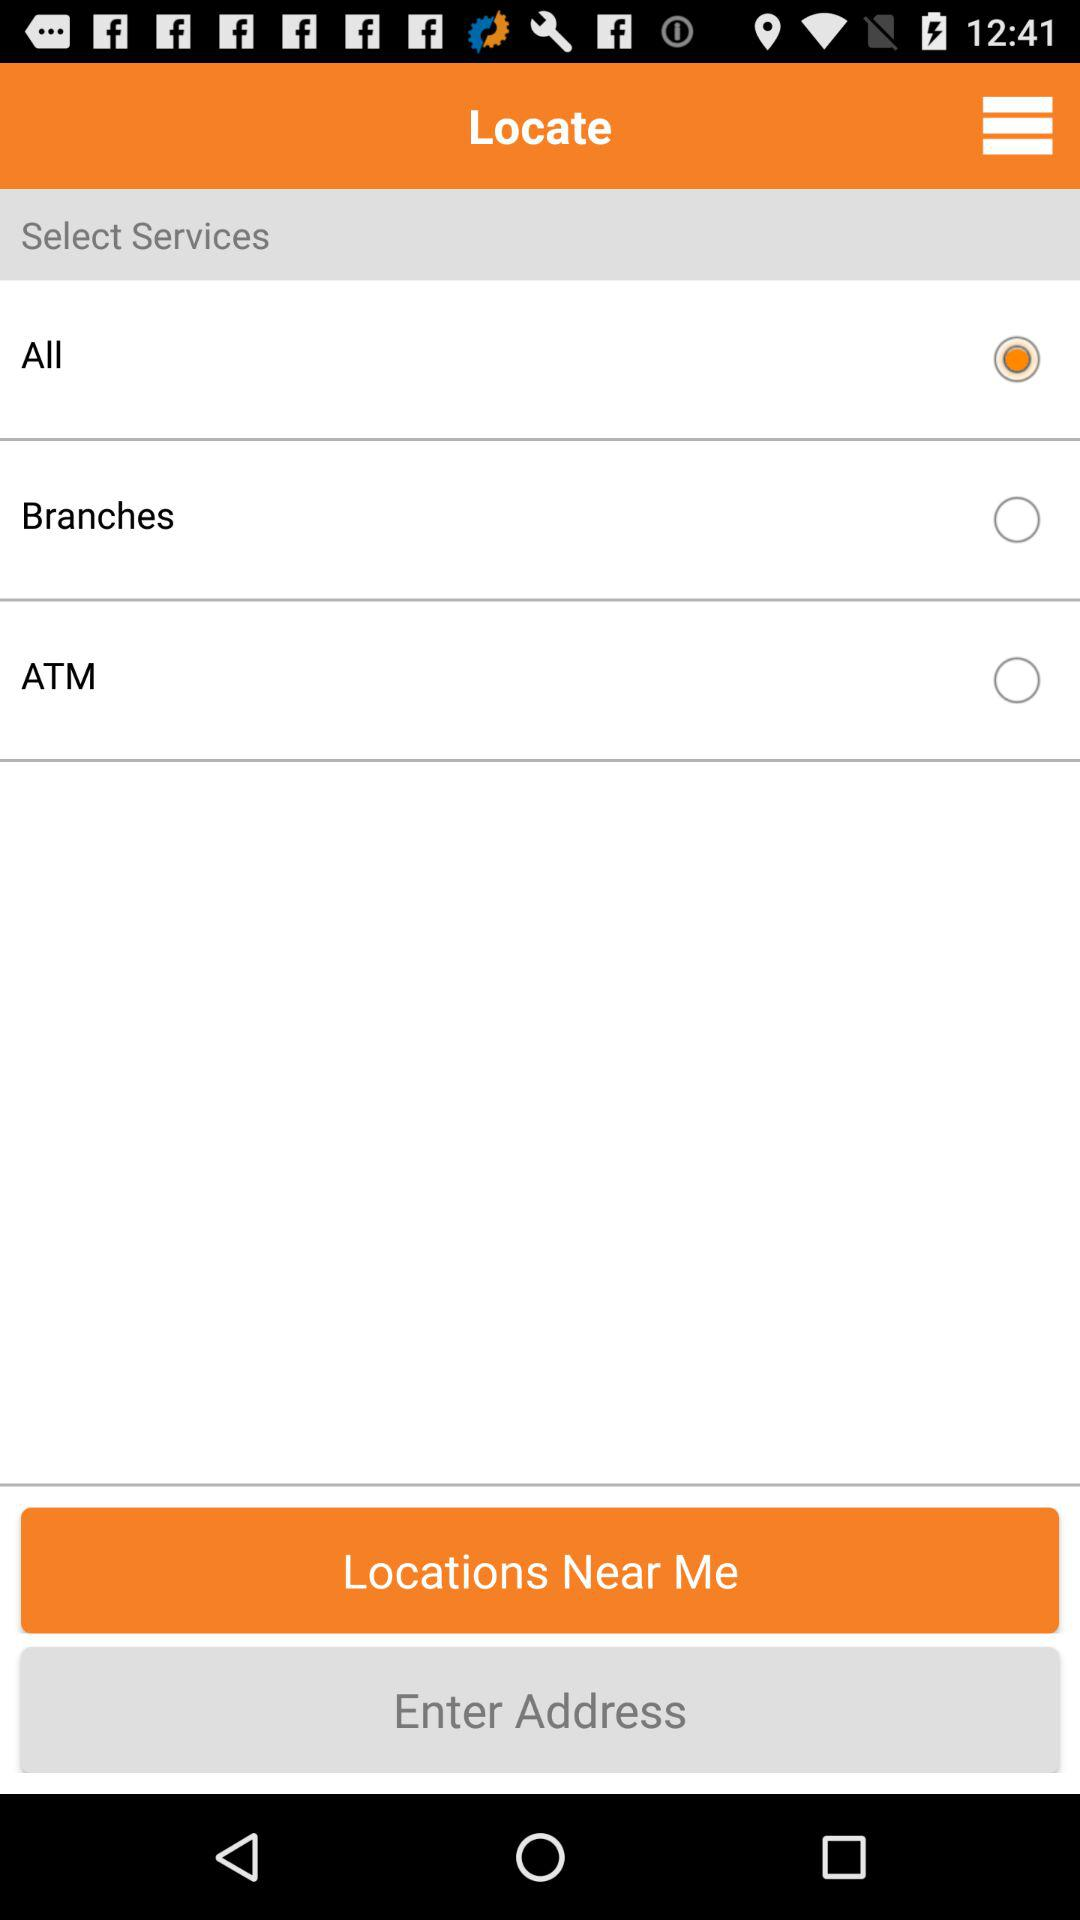What is the selected option? The selected option is "All". 